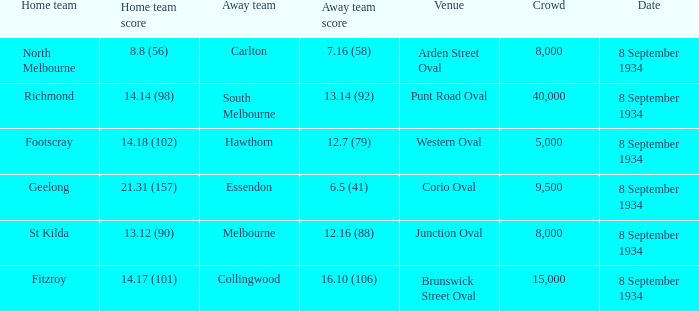When Melbourne was the Away team, what was their score? 12.16 (88). 